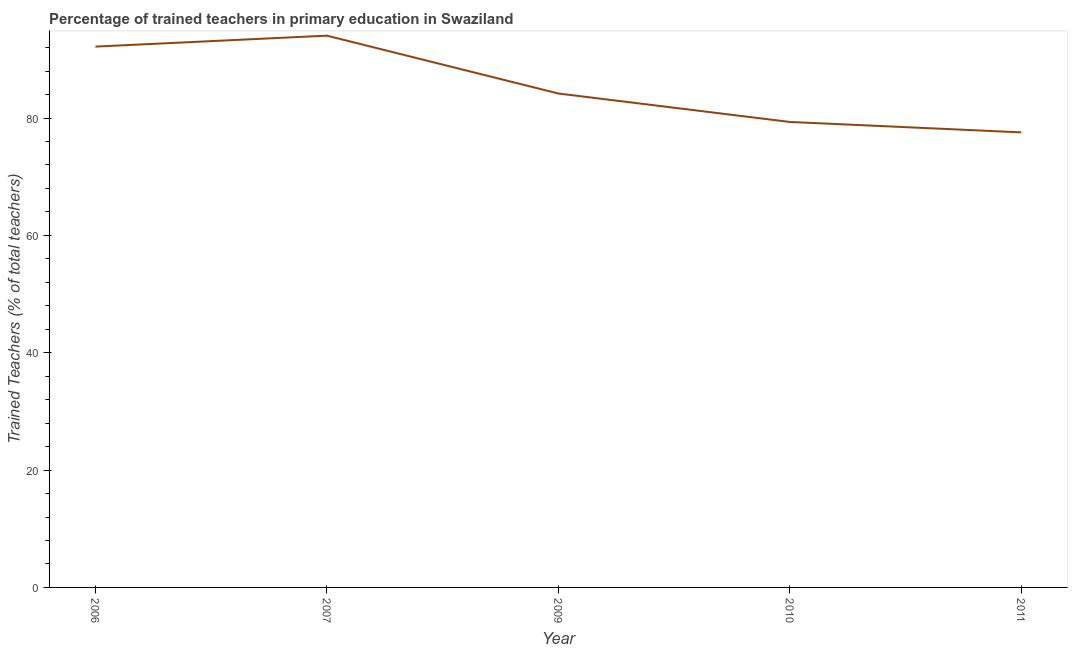What is the percentage of trained teachers in 2006?
Offer a very short reply. 92.18. Across all years, what is the maximum percentage of trained teachers?
Your answer should be compact. 94.04. Across all years, what is the minimum percentage of trained teachers?
Offer a very short reply. 77.56. In which year was the percentage of trained teachers maximum?
Your answer should be very brief. 2007. What is the sum of the percentage of trained teachers?
Offer a very short reply. 427.31. What is the difference between the percentage of trained teachers in 2009 and 2010?
Make the answer very short. 4.85. What is the average percentage of trained teachers per year?
Give a very brief answer. 85.46. What is the median percentage of trained teachers?
Offer a terse response. 84.19. Do a majority of the years between 2011 and 2007 (inclusive) have percentage of trained teachers greater than 72 %?
Provide a short and direct response. Yes. What is the ratio of the percentage of trained teachers in 2006 to that in 2007?
Offer a terse response. 0.98. Is the percentage of trained teachers in 2010 less than that in 2011?
Your response must be concise. No. Is the difference between the percentage of trained teachers in 2006 and 2009 greater than the difference between any two years?
Your answer should be very brief. No. What is the difference between the highest and the second highest percentage of trained teachers?
Your answer should be very brief. 1.86. Is the sum of the percentage of trained teachers in 2006 and 2011 greater than the maximum percentage of trained teachers across all years?
Provide a short and direct response. Yes. What is the difference between the highest and the lowest percentage of trained teachers?
Your answer should be very brief. 16.48. In how many years, is the percentage of trained teachers greater than the average percentage of trained teachers taken over all years?
Ensure brevity in your answer.  2. How many years are there in the graph?
Make the answer very short. 5. What is the difference between two consecutive major ticks on the Y-axis?
Offer a very short reply. 20. Does the graph contain any zero values?
Make the answer very short. No. Does the graph contain grids?
Your answer should be compact. No. What is the title of the graph?
Provide a succinct answer. Percentage of trained teachers in primary education in Swaziland. What is the label or title of the Y-axis?
Give a very brief answer. Trained Teachers (% of total teachers). What is the Trained Teachers (% of total teachers) in 2006?
Ensure brevity in your answer.  92.18. What is the Trained Teachers (% of total teachers) in 2007?
Your response must be concise. 94.04. What is the Trained Teachers (% of total teachers) of 2009?
Offer a very short reply. 84.19. What is the Trained Teachers (% of total teachers) in 2010?
Offer a terse response. 79.34. What is the Trained Teachers (% of total teachers) of 2011?
Provide a short and direct response. 77.56. What is the difference between the Trained Teachers (% of total teachers) in 2006 and 2007?
Your answer should be compact. -1.86. What is the difference between the Trained Teachers (% of total teachers) in 2006 and 2009?
Your answer should be very brief. 7.99. What is the difference between the Trained Teachers (% of total teachers) in 2006 and 2010?
Your answer should be compact. 12.84. What is the difference between the Trained Teachers (% of total teachers) in 2006 and 2011?
Provide a succinct answer. 14.62. What is the difference between the Trained Teachers (% of total teachers) in 2007 and 2009?
Ensure brevity in your answer.  9.86. What is the difference between the Trained Teachers (% of total teachers) in 2007 and 2010?
Your response must be concise. 14.71. What is the difference between the Trained Teachers (% of total teachers) in 2007 and 2011?
Your answer should be compact. 16.48. What is the difference between the Trained Teachers (% of total teachers) in 2009 and 2010?
Keep it short and to the point. 4.85. What is the difference between the Trained Teachers (% of total teachers) in 2009 and 2011?
Your response must be concise. 6.62. What is the difference between the Trained Teachers (% of total teachers) in 2010 and 2011?
Your response must be concise. 1.78. What is the ratio of the Trained Teachers (% of total teachers) in 2006 to that in 2007?
Provide a short and direct response. 0.98. What is the ratio of the Trained Teachers (% of total teachers) in 2006 to that in 2009?
Give a very brief answer. 1.09. What is the ratio of the Trained Teachers (% of total teachers) in 2006 to that in 2010?
Ensure brevity in your answer.  1.16. What is the ratio of the Trained Teachers (% of total teachers) in 2006 to that in 2011?
Your answer should be compact. 1.19. What is the ratio of the Trained Teachers (% of total teachers) in 2007 to that in 2009?
Provide a succinct answer. 1.12. What is the ratio of the Trained Teachers (% of total teachers) in 2007 to that in 2010?
Offer a terse response. 1.19. What is the ratio of the Trained Teachers (% of total teachers) in 2007 to that in 2011?
Ensure brevity in your answer.  1.21. What is the ratio of the Trained Teachers (% of total teachers) in 2009 to that in 2010?
Offer a terse response. 1.06. What is the ratio of the Trained Teachers (% of total teachers) in 2009 to that in 2011?
Your answer should be very brief. 1.08. 